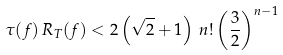Convert formula to latex. <formula><loc_0><loc_0><loc_500><loc_500>\tau ( f ) \, R _ { T } ( f ) < 2 \left ( \sqrt { 2 } + 1 \right ) \, n ! \left ( \frac { 3 } { 2 } \right ) ^ { n - 1 }</formula> 